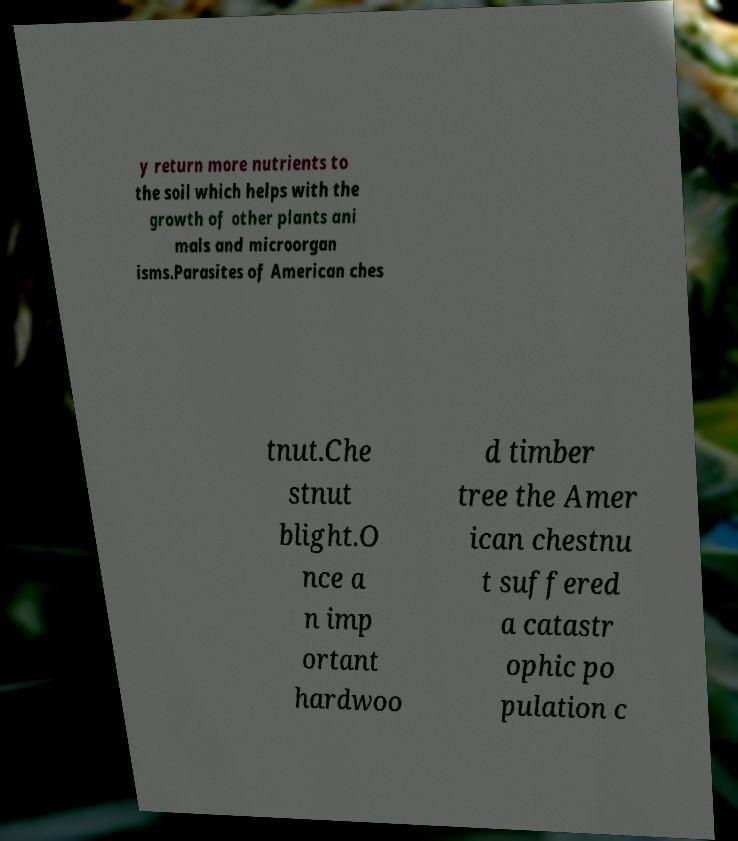Can you read and provide the text displayed in the image?This photo seems to have some interesting text. Can you extract and type it out for me? y return more nutrients to the soil which helps with the growth of other plants ani mals and microorgan isms.Parasites of American ches tnut.Che stnut blight.O nce a n imp ortant hardwoo d timber tree the Amer ican chestnu t suffered a catastr ophic po pulation c 